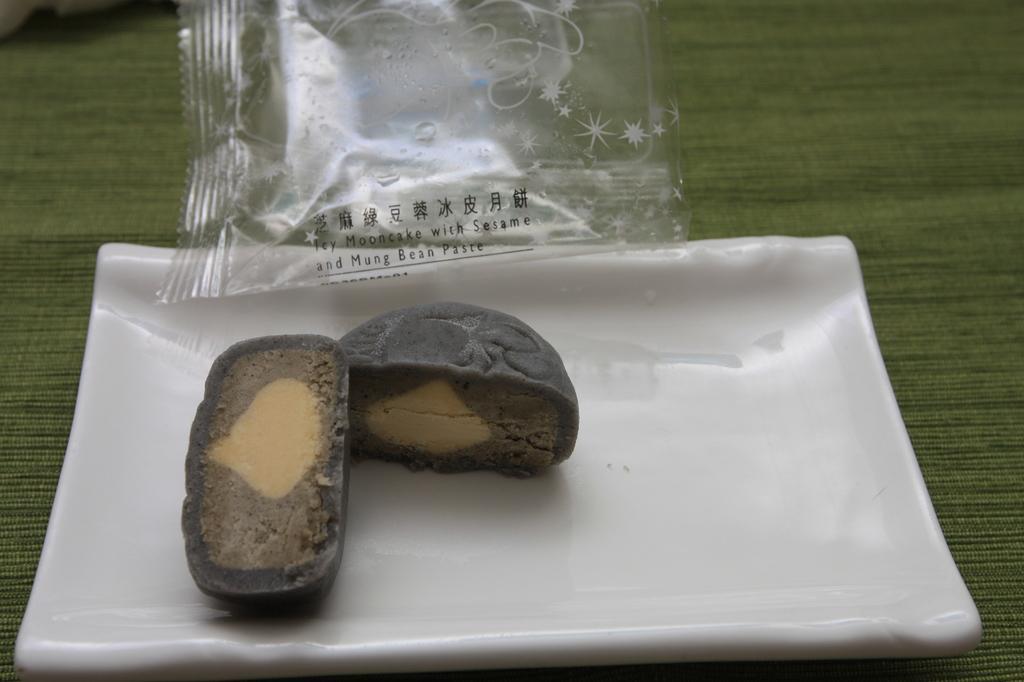Please provide a concise description of this image. In this picture I can see some eatable item kept in the plate. 